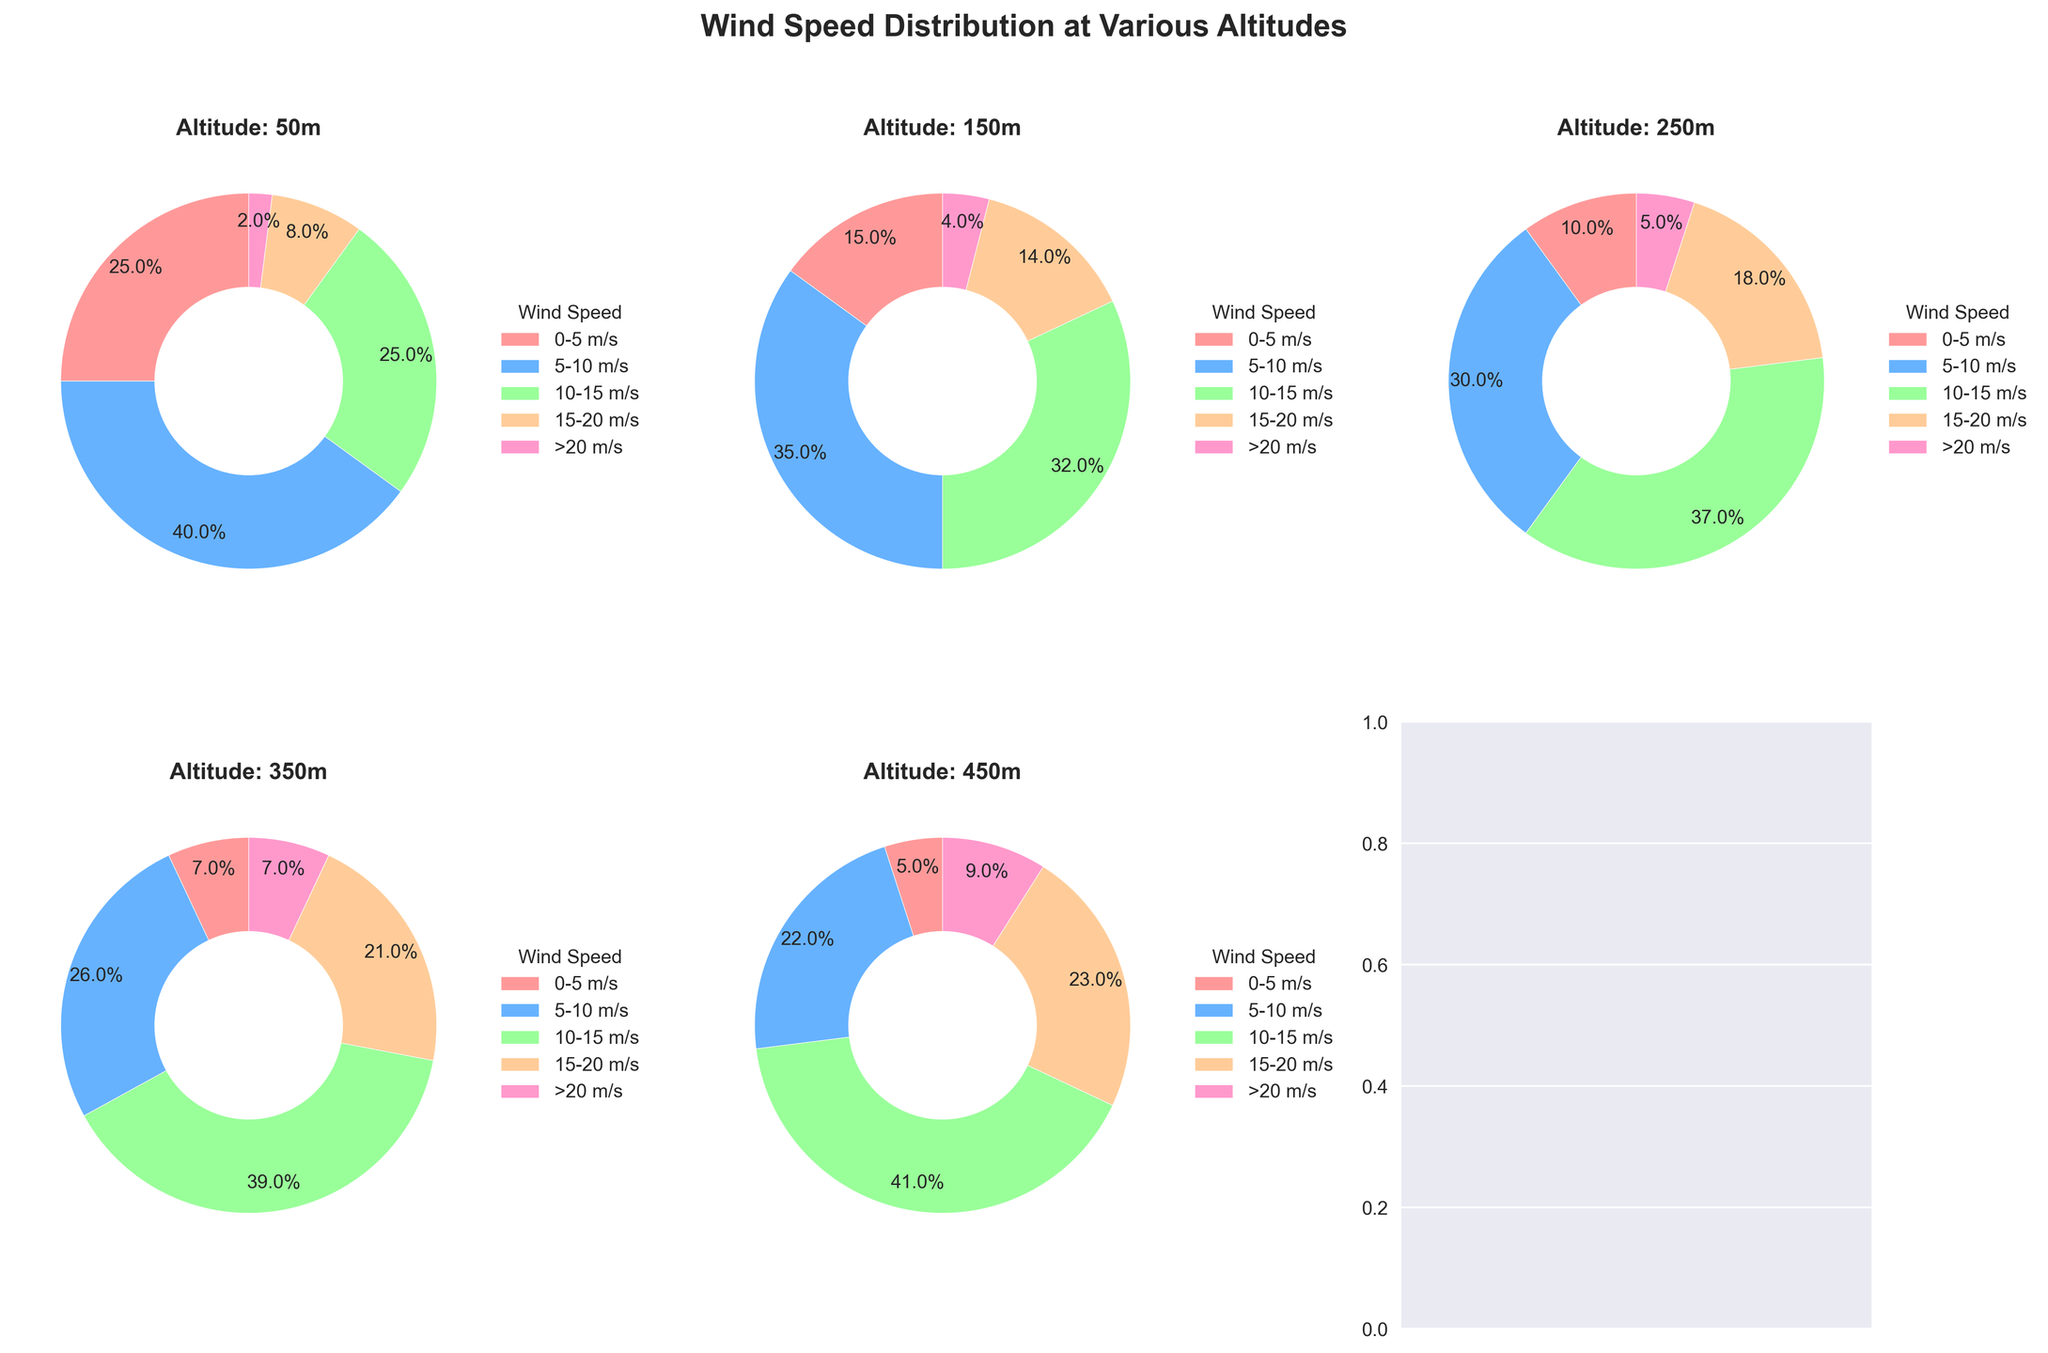What's the cumulative percentage of wind speeds between 0-10 m/s at an altitude of 200 m? At 200 m, the percentages of wind speeds 0-5 m/s and 5-10 m/s are 12% and 32% respectively. Adding them together, we get 12% + 32% = 44%.
Answer: 44% Which altitude has the highest percentage of wind speeds greater than 20 m/s? From the figure, we can compare the final segment of each pie chart representing '>20 m/s'. The altitude with the highest percentage in this segment is 500 m with 10%.
Answer: 500 m How does the percentage of wind speeds in the 10-15 m/s range change from 50 m to 250 m? At 50 m, the percentage is 25%. At 100 m, it is 28%. At 150 m, it is 32%. At 200 m, it is 35%. At 250 m, it is 37%. The change is 37% - 25% = 12%.
Answer: 12% Which altitude has the smallest percentage of wind speeds between 0-5 m/s? By comparing the first segment of each pie chart, the altitude with the smallest percentage in the '0-5 m/s' category is 500 m with 4%.
Answer: 500 m At an altitude of 350 m, what is the combined percentage for wind speeds in the ranges of 10-15 m/s and 15-20 m/s? At 350 m, the percentage for 10-15 m/s is 39% and for 15-20 m/s is 21%. Combined, the total is 39% + 21% = 60%.
Answer: 60% Compare the percentages of wind speeds between 10-20 m/s at 100 m and 300 m. Which altitude has a higher percentage? At 100 m, the percentage for 10-15 m/s is 28% and for 15-20 m/s is 11%, adding up to 39%. At 300 m, the percentage for 10-15 m/s is 38% and for 15-20 m/s is 20%, adding up to 58%. Thus, 300 m has a higher percentage.
Answer: 300 m What is the difference in the percentage of wind speeds >20 m/s between the altitudes of 250 m and 450 m? At 250 m, the percentage for '>20 m/s' is 5%. At 450 m, it is 9%. The difference is 9% - 5% = 4%.
Answer: 4% Which wind speed category shows an increasing trend with altitude? Observing the pie charts, the '>20 m/s' category shows an increasing trend as altitude increases.
Answer: '>20 m/s' How does the percentage of wind speeds in the 5-10 m/s range change from 50 m to 50 m over the altitudes? At 50 m, it is 40%, and gradually decreases in each subsequent pie chart. The trend is a decrease as the altitude increases.
Answer: Decreasing 